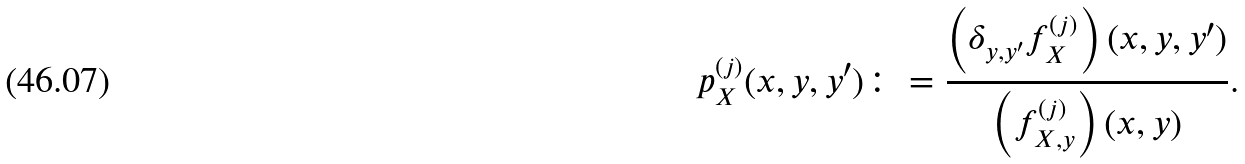<formula> <loc_0><loc_0><loc_500><loc_500>p _ { X } ^ { ( j ) } ( x , y , y ^ { \prime } ) \colon = \frac { \left ( \delta _ { y , y ^ { \prime } } f _ { X } ^ { ( j ) } \right ) ( x , y , y ^ { \prime } ) } { \left ( f _ { X , y } ^ { ( j ) } \right ) ( x , y ) } .</formula> 